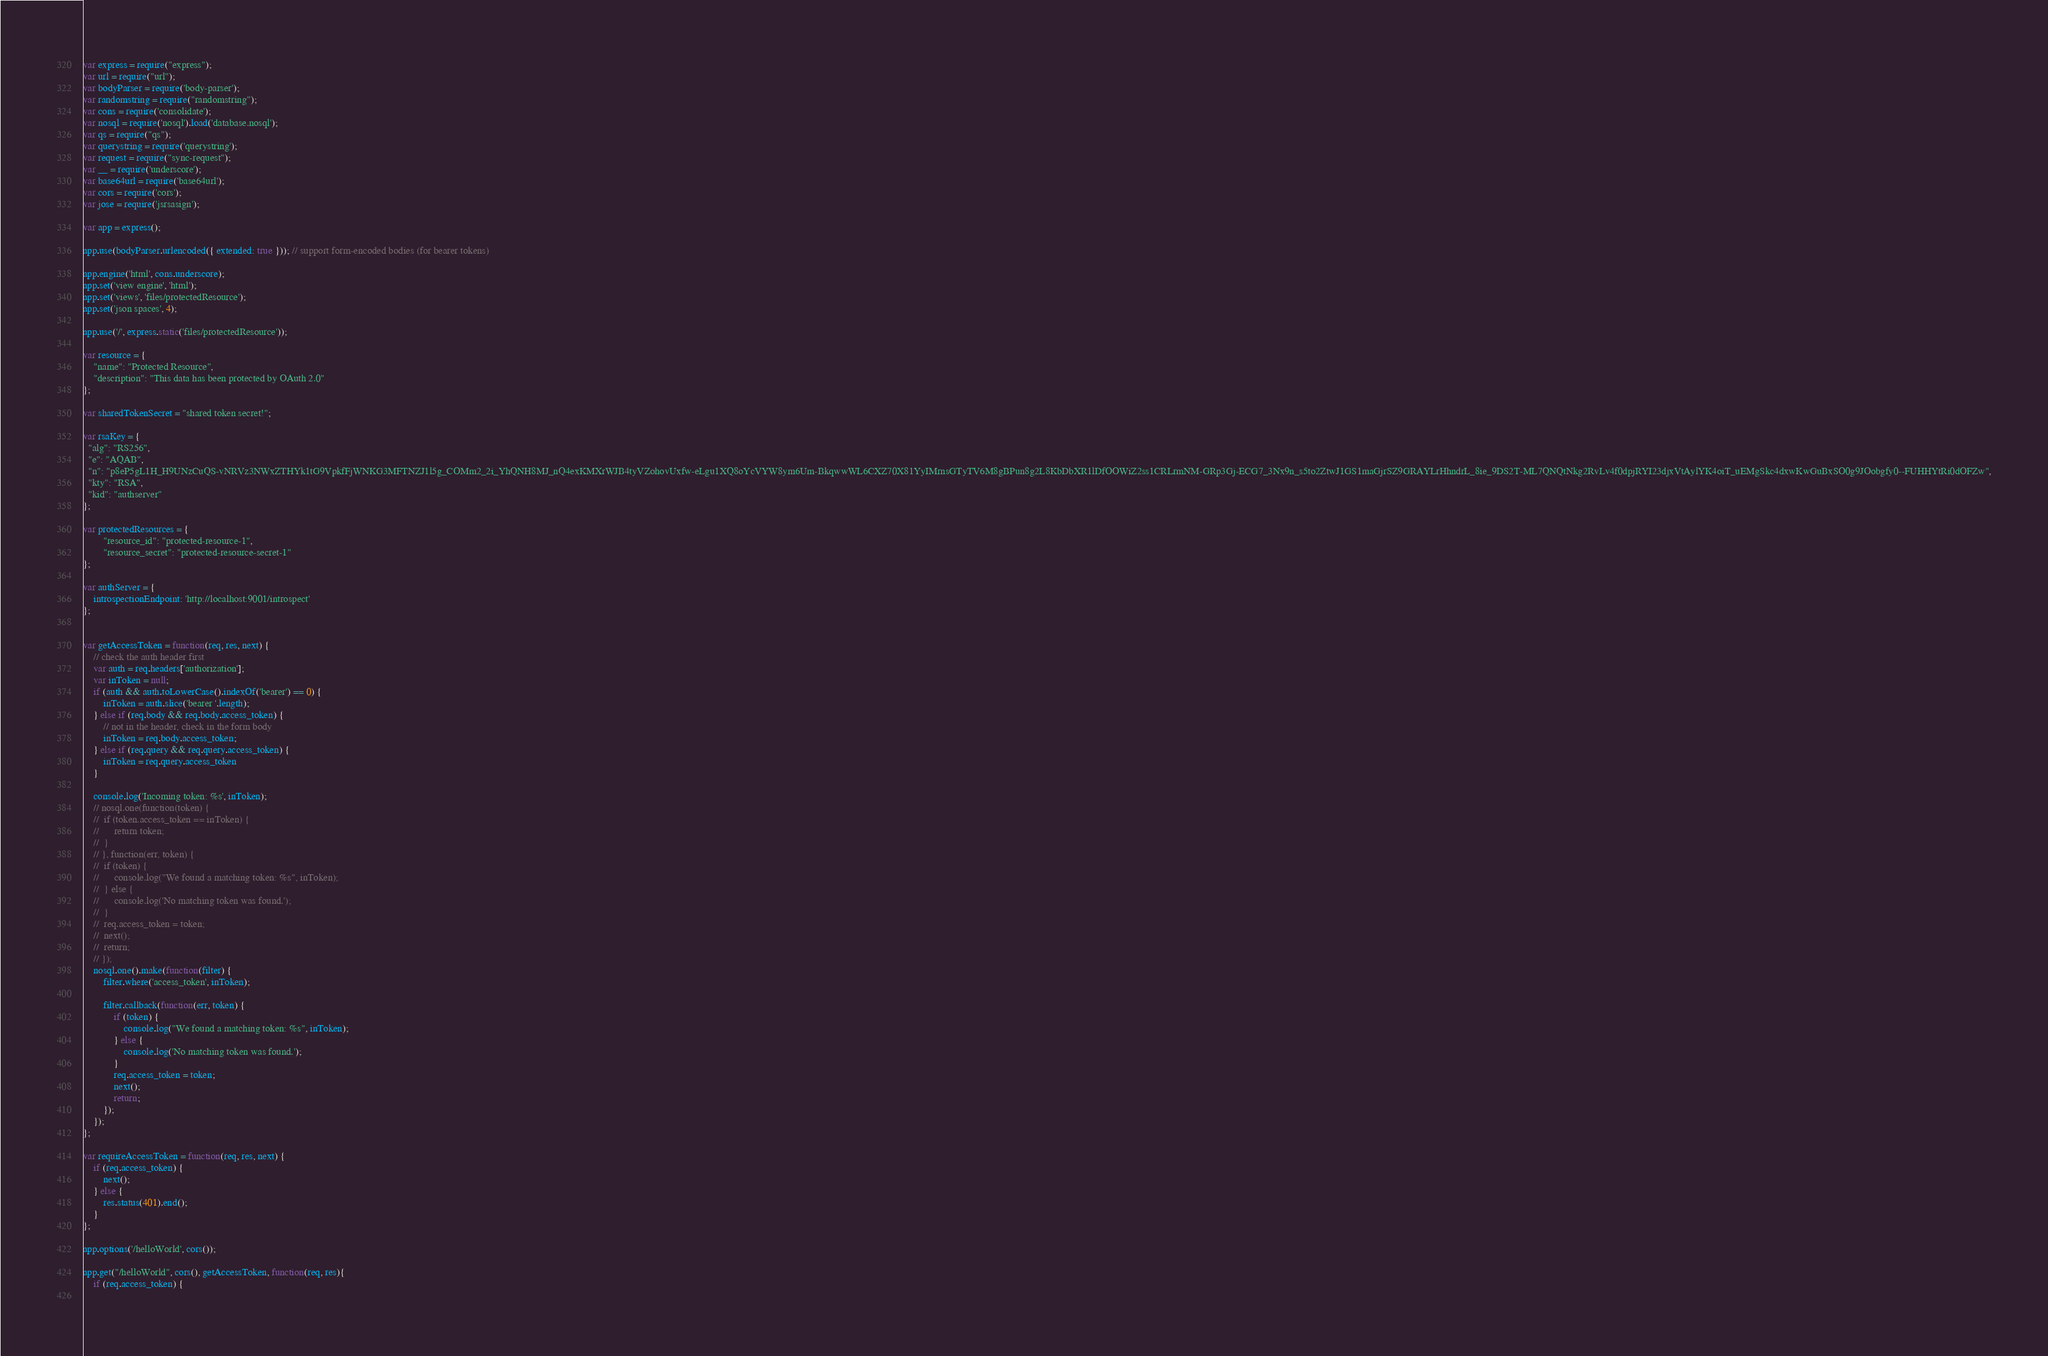Convert code to text. <code><loc_0><loc_0><loc_500><loc_500><_JavaScript_>var express = require("express");
var url = require("url");
var bodyParser = require('body-parser');
var randomstring = require("randomstring");
var cons = require('consolidate');
var nosql = require('nosql').load('database.nosql');
var qs = require("qs");
var querystring = require('querystring');
var request = require("sync-request");
var __ = require('underscore');
var base64url = require('base64url');
var cors = require('cors');
var jose = require('jsrsasign');

var app = express();

app.use(bodyParser.urlencoded({ extended: true })); // support form-encoded bodies (for bearer tokens)

app.engine('html', cons.underscore);
app.set('view engine', 'html');
app.set('views', 'files/protectedResource');
app.set('json spaces', 4);

app.use('/', express.static('files/protectedResource'));

var resource = {
	"name": "Protected Resource",
	"description": "This data has been protected by OAuth 2.0"
};

var sharedTokenSecret = "shared token secret!";

var rsaKey = {
  "alg": "RS256",
  "e": "AQAB",
  "n": "p8eP5gL1H_H9UNzCuQS-vNRVz3NWxZTHYk1tG9VpkfFjWNKG3MFTNZJ1l5g_COMm2_2i_YhQNH8MJ_nQ4exKMXrWJB4tyVZohovUxfw-eLgu1XQ8oYcVYW8ym6Um-BkqwwWL6CXZ70X81YyIMrnsGTyTV6M8gBPun8g2L8KbDbXR1lDfOOWiZ2ss1CRLrmNM-GRp3Gj-ECG7_3Nx9n_s5to2ZtwJ1GS1maGjrSZ9GRAYLrHhndrL_8ie_9DS2T-ML7QNQtNkg2RvLv4f0dpjRYI23djxVtAylYK4oiT_uEMgSkc4dxwKwGuBxSO0g9JOobgfy0--FUHHYtRi0dOFZw",
  "kty": "RSA",
  "kid": "authserver"
};

var protectedResources = {
		"resource_id": "protected-resource-1",
		"resource_secret": "protected-resource-secret-1"
};

var authServer = {
	introspectionEndpoint: 'http://localhost:9001/introspect'
};


var getAccessToken = function(req, res, next) {
	// check the auth header first
	var auth = req.headers['authorization'];
	var inToken = null;
	if (auth && auth.toLowerCase().indexOf('bearer') == 0) {
		inToken = auth.slice('bearer '.length);
	} else if (req.body && req.body.access_token) {
		// not in the header, check in the form body
		inToken = req.body.access_token;
	} else if (req.query && req.query.access_token) {
		inToken = req.query.access_token
	}
	
	console.log('Incoming token: %s', inToken);
	// nosql.one(function(token) {
	// 	if (token.access_token == inToken) {
	// 		return token;	
	// 	}
	// }, function(err, token) {
	// 	if (token) {
	// 		console.log("We found a matching token: %s", inToken);
	// 	} else {
	// 		console.log('No matching token was found.');
	// 	}
	// 	req.access_token = token;
	// 	next();
	// 	return;
	// });
	nosql.one().make(function(filter) {
		filter.where('access_token', inToken);
	
		filter.callback(function(err, token) {
			if (token) {
				console.log("We found a matching token: %s", inToken);
			} else {
				console.log('No matching token was found.');
			}
			req.access_token = token;
			next();
			return;
		});
	});
};

var requireAccessToken = function(req, res, next) {
	if (req.access_token) {
		next();
	} else {
		res.status(401).end();
	}
}; 

app.options('/helloWorld', cors());

app.get("/helloWorld", cors(), getAccessToken, function(req, res){
	if (req.access_token) {
		</code> 